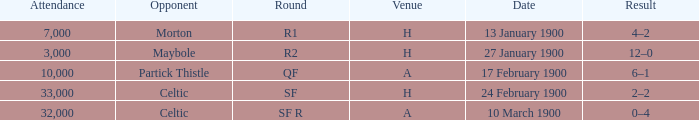How many people attended in the game against morton? 7000.0. 